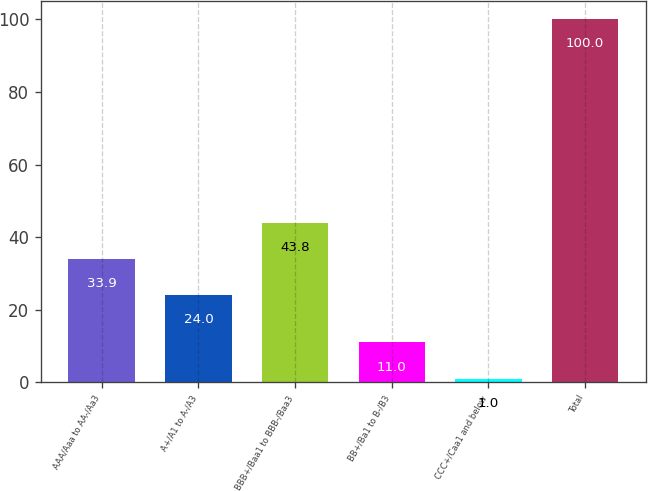Convert chart. <chart><loc_0><loc_0><loc_500><loc_500><bar_chart><fcel>AAA/Aaa to AA-/Aa3<fcel>A+/A1 to A-/A3<fcel>BBB+/Baa1 to BBB-/Baa3<fcel>BB+/Ba1 to B-/B3<fcel>CCC+/Caa1 and below<fcel>Total<nl><fcel>33.9<fcel>24<fcel>43.8<fcel>11<fcel>1<fcel>100<nl></chart> 